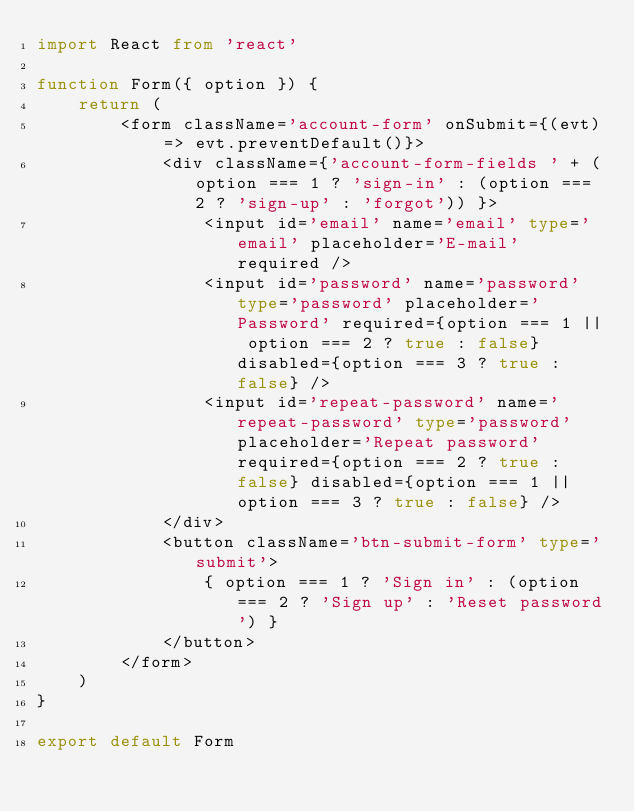Convert code to text. <code><loc_0><loc_0><loc_500><loc_500><_TypeScript_>import React from 'react'

function Form({ option }) {
    return (
        <form className='account-form' onSubmit={(evt) => evt.preventDefault()}>
			<div className={'account-form-fields ' + (option === 1 ? 'sign-in' : (option === 2 ? 'sign-up' : 'forgot')) }>
				<input id='email' name='email' type='email' placeholder='E-mail' required />
				<input id='password' name='password' type='password' placeholder='Password' required={option === 1 || option === 2 ? true : false} disabled={option === 3 ? true : false} />
				<input id='repeat-password' name='repeat-password' type='password' placeholder='Repeat password' required={option === 2 ? true : false} disabled={option === 1 || option === 3 ? true : false} />
			</div>
			<button className='btn-submit-form' type='submit'>
				{ option === 1 ? 'Sign in' : (option === 2 ? 'Sign up' : 'Reset password') }
			</button>
		</form>
    )
}

export default Form
</code> 